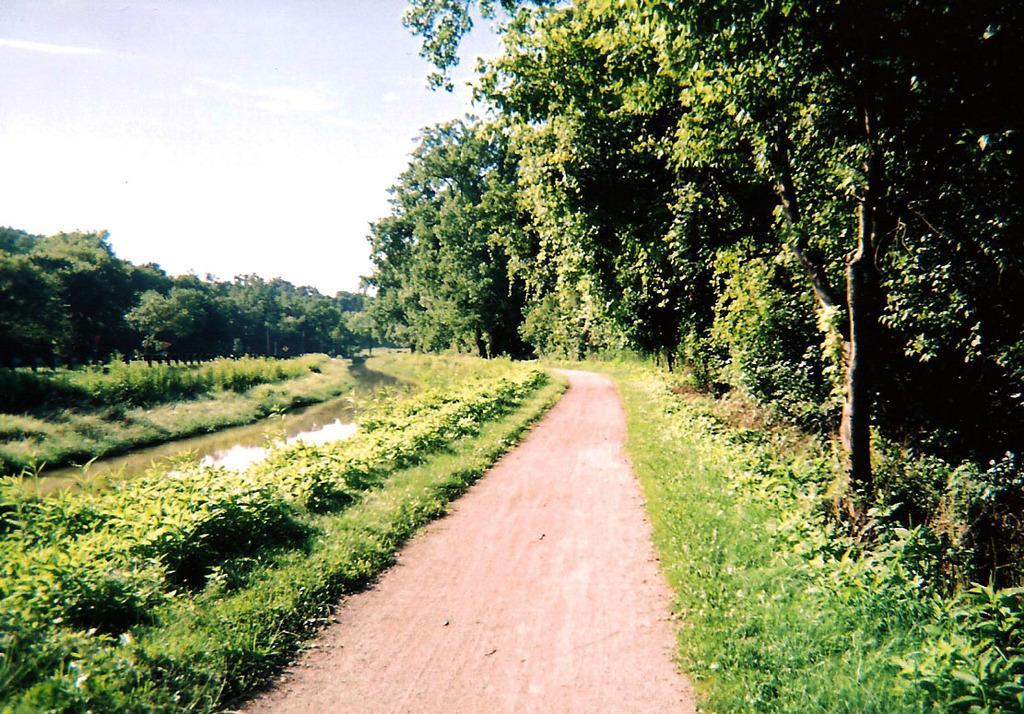How would you summarize this image in a sentence or two? This image is taken outdoors. At the top of the image there is the sky with clouds. At the bottom of the image there is a ground with grass on it. In the background there are many trees and plants with leaves, stems and branches. On the left side of the image there is a lake with water. 